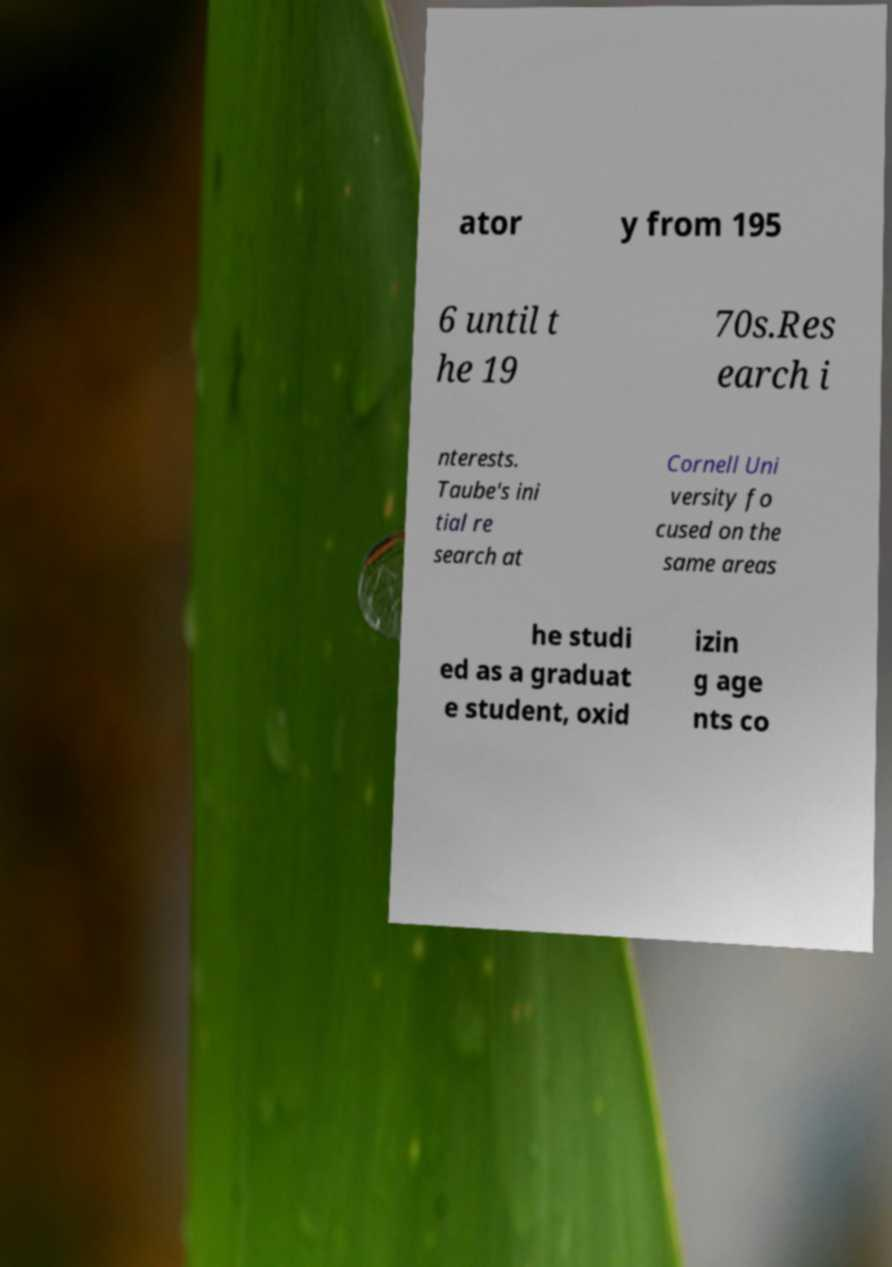I need the written content from this picture converted into text. Can you do that? ator y from 195 6 until t he 19 70s.Res earch i nterests. Taube's ini tial re search at Cornell Uni versity fo cused on the same areas he studi ed as a graduat e student, oxid izin g age nts co 